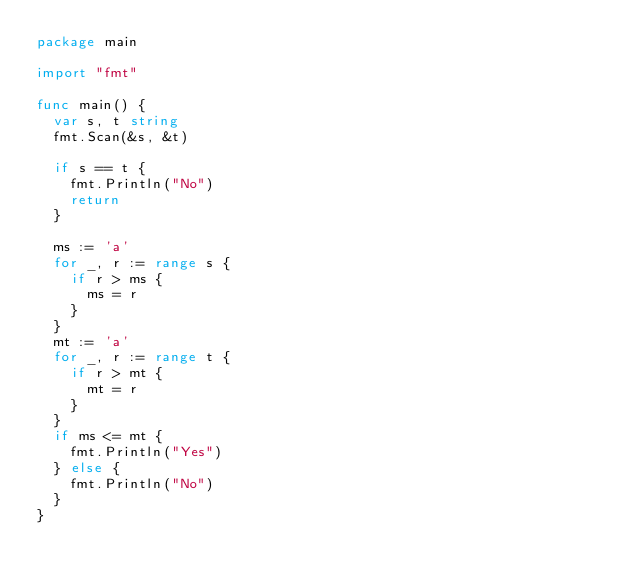Convert code to text. <code><loc_0><loc_0><loc_500><loc_500><_Go_>package main

import "fmt"

func main() {
	var s, t string
	fmt.Scan(&s, &t)

	if s == t {
		fmt.Println("No")
		return
	}

	ms := 'a'
	for _, r := range s {
		if r > ms {
			ms = r
		}
	}
	mt := 'a'
	for _, r := range t {
		if r > mt {
			mt = r
		}
	}
	if ms <= mt {
		fmt.Println("Yes")
	} else {
		fmt.Println("No")
	}
}
</code> 